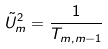Convert formula to latex. <formula><loc_0><loc_0><loc_500><loc_500>\tilde { U } _ { m } ^ { 2 } = \frac { 1 } { T _ { m , m - 1 } }</formula> 